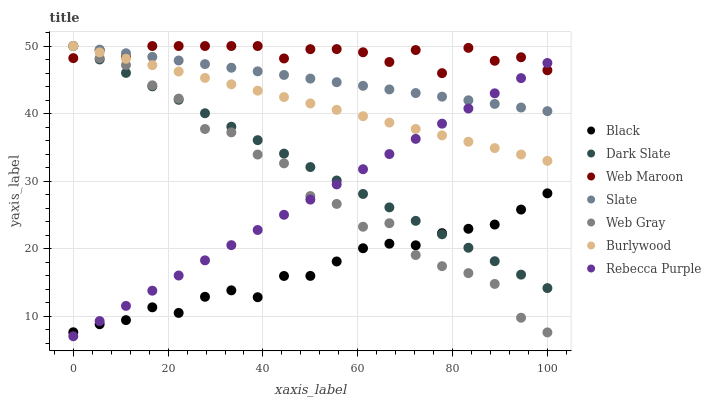Does Black have the minimum area under the curve?
Answer yes or no. Yes. Does Web Maroon have the maximum area under the curve?
Answer yes or no. Yes. Does Burlywood have the minimum area under the curve?
Answer yes or no. No. Does Burlywood have the maximum area under the curve?
Answer yes or no. No. Is Rebecca Purple the smoothest?
Answer yes or no. Yes. Is Web Gray the roughest?
Answer yes or no. Yes. Is Burlywood the smoothest?
Answer yes or no. No. Is Burlywood the roughest?
Answer yes or no. No. Does Rebecca Purple have the lowest value?
Answer yes or no. Yes. Does Burlywood have the lowest value?
Answer yes or no. No. Does Dark Slate have the highest value?
Answer yes or no. Yes. Does Black have the highest value?
Answer yes or no. No. Is Black less than Web Maroon?
Answer yes or no. Yes. Is Slate greater than Black?
Answer yes or no. Yes. Does Slate intersect Web Gray?
Answer yes or no. Yes. Is Slate less than Web Gray?
Answer yes or no. No. Is Slate greater than Web Gray?
Answer yes or no. No. Does Black intersect Web Maroon?
Answer yes or no. No. 